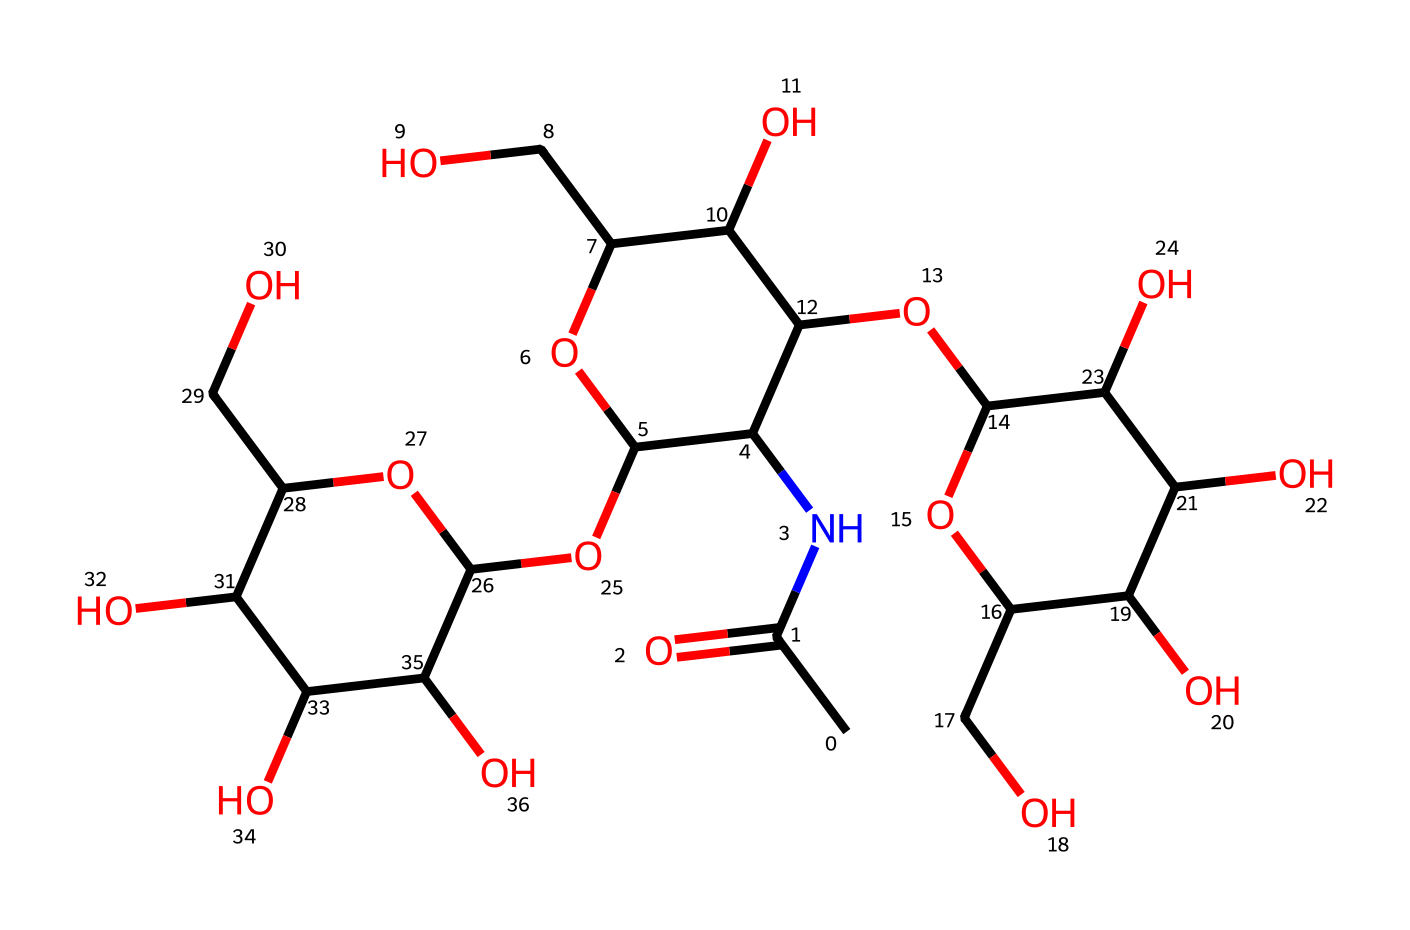What is the name of this chemical? The SMILES representation indicates the structure contains multiple hydroxyl (–OH) groups typical of polysaccharides, and the presence of acetamide group (CC(=O)N), which collectively identify it as hyaluronic acid.
Answer: hyaluronic acid How many oxygen atoms are present in this structure? By examining the SMILES representation, we can count the total number of ‘O’ characters, which indicates the presence of 10 oxygen atoms in the chemical structure.
Answer: 10 What type of functional group is present at the start of the SMILES? The structure starts with a carbonyl (C=O) and an amine (N), indicating the presence of an acetamide functional group.
Answer: acetamide How many carbons are in this molecule? Counting the ‘C’ characters in the SMILES representation gives a total of 18 carbon atoms in the hyaluronic acid molecule.
Answer: 18 Is this molecule acidic or basic? The presence of hydroxyl groups (–OH) reflects it can donate protons, thus displaying acidic behavior, despite being predominantly neutral in biological systems.
Answer: acidic What is the primary role of hyaluronic acid in joint supplements? Hyaluronic acid primarily acts as a lubricant and shock absorber in the synovial fluid of joints, contributing to cushioning and joint health.
Answer: lubricant 